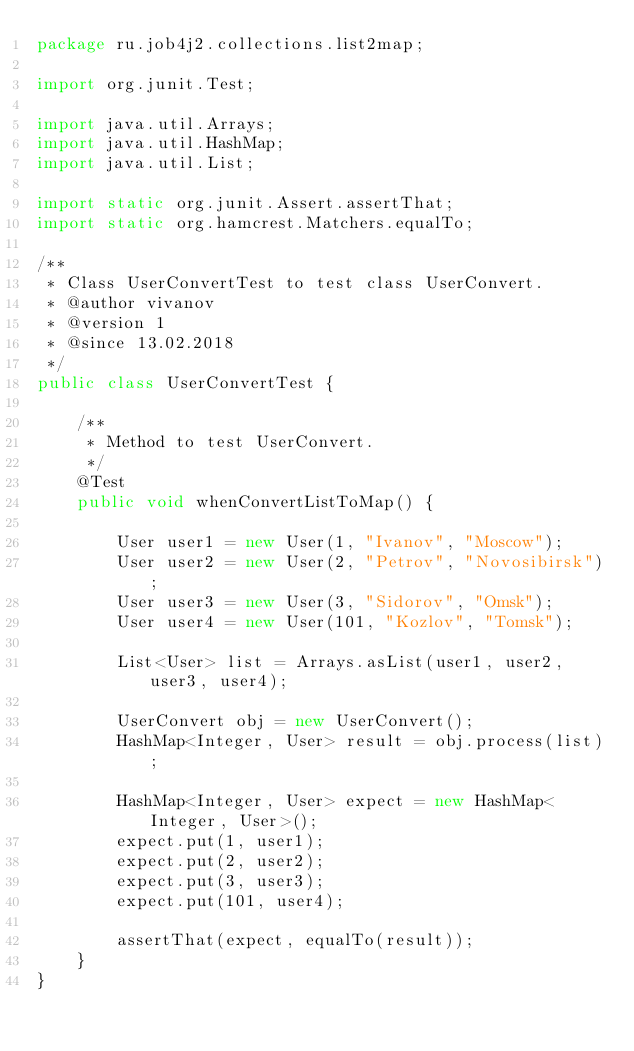Convert code to text. <code><loc_0><loc_0><loc_500><loc_500><_Java_>package ru.job4j2.collections.list2map;

import org.junit.Test;

import java.util.Arrays;
import java.util.HashMap;
import java.util.List;

import static org.junit.Assert.assertThat;
import static org.hamcrest.Matchers.equalTo;

/**
 * Class UserConvertTest to test class UserConvert.
 * @author vivanov
 * @version 1
 * @since 13.02.2018
 */
public class UserConvertTest {

    /**
     * Method to test UserConvert.
     */
    @Test
    public void whenConvertListToMap() {

        User user1 = new User(1, "Ivanov", "Moscow");
        User user2 = new User(2, "Petrov", "Novosibirsk");
        User user3 = new User(3, "Sidorov", "Omsk");
        User user4 = new User(101, "Kozlov", "Tomsk");

        List<User> list = Arrays.asList(user1, user2, user3, user4);

        UserConvert obj = new UserConvert();
        HashMap<Integer, User> result = obj.process(list);

        HashMap<Integer, User> expect = new HashMap<Integer, User>();
        expect.put(1, user1);
        expect.put(2, user2);
        expect.put(3, user3);
        expect.put(101, user4);

        assertThat(expect, equalTo(result));
    }
}
</code> 